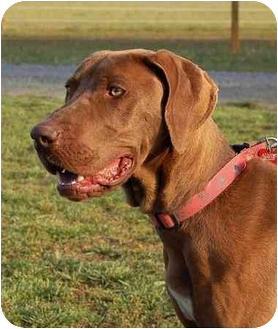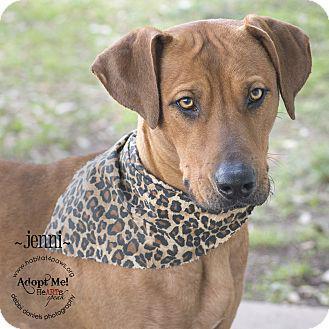The first image is the image on the left, the second image is the image on the right. For the images displayed, is the sentence "The dog on the left is wearing a brightly colored, clearly visible collar, while the dog on the right is seemingly not wearing a collar or anything else around it's neck." factually correct? Answer yes or no. No. The first image is the image on the left, the second image is the image on the right. For the images displayed, is the sentence "The left image features a close-mouthed dog in a collar gazing up and to the left, and the right image features a puppy with a wrinkly mouth." factually correct? Answer yes or no. No. 